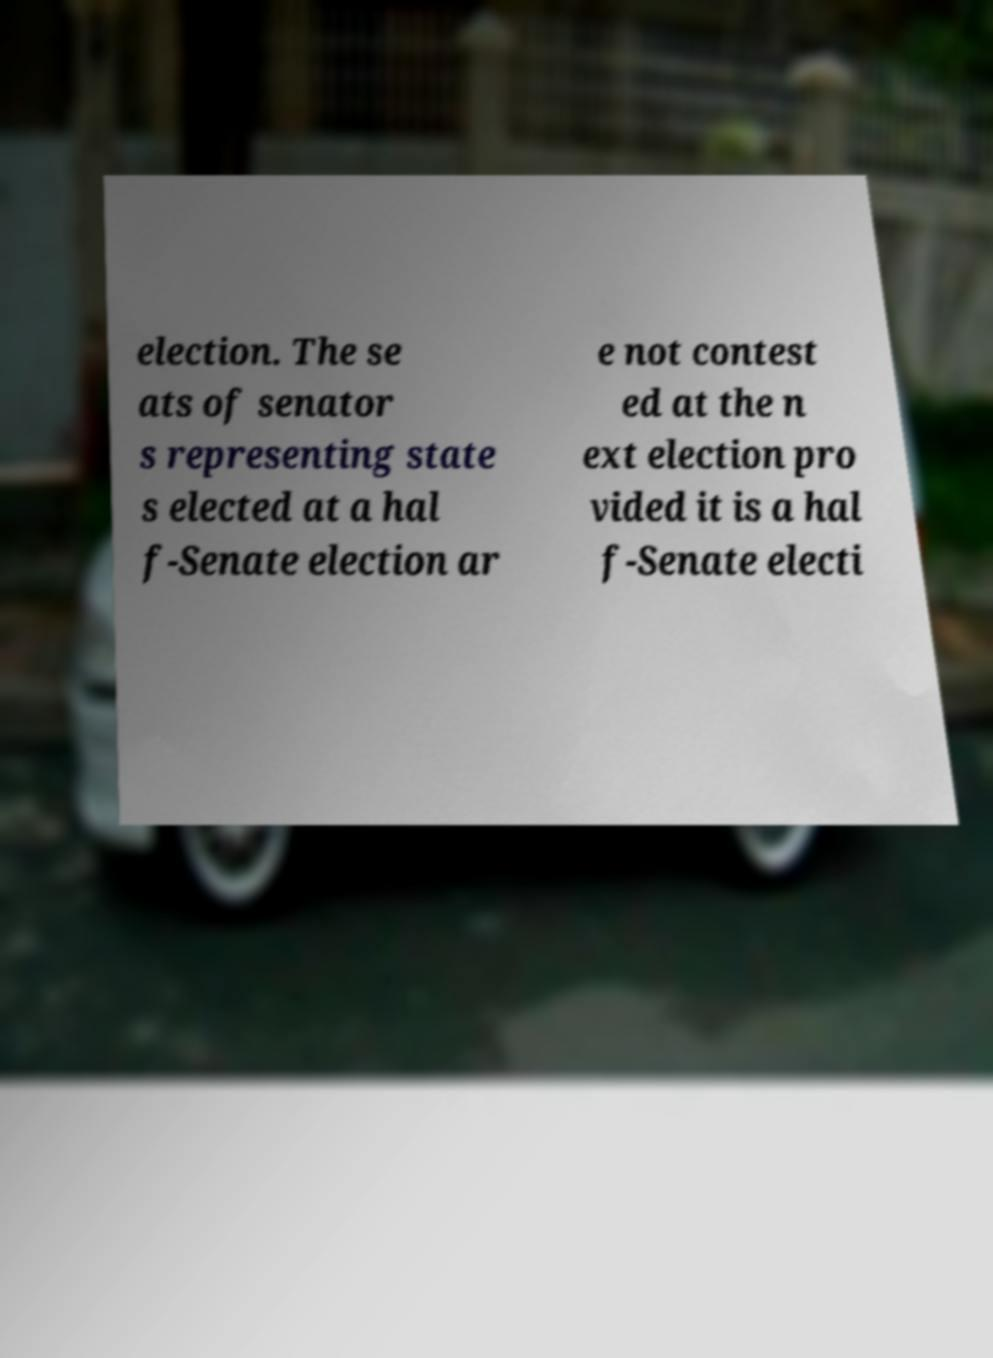For documentation purposes, I need the text within this image transcribed. Could you provide that? election. The se ats of senator s representing state s elected at a hal f-Senate election ar e not contest ed at the n ext election pro vided it is a hal f-Senate electi 